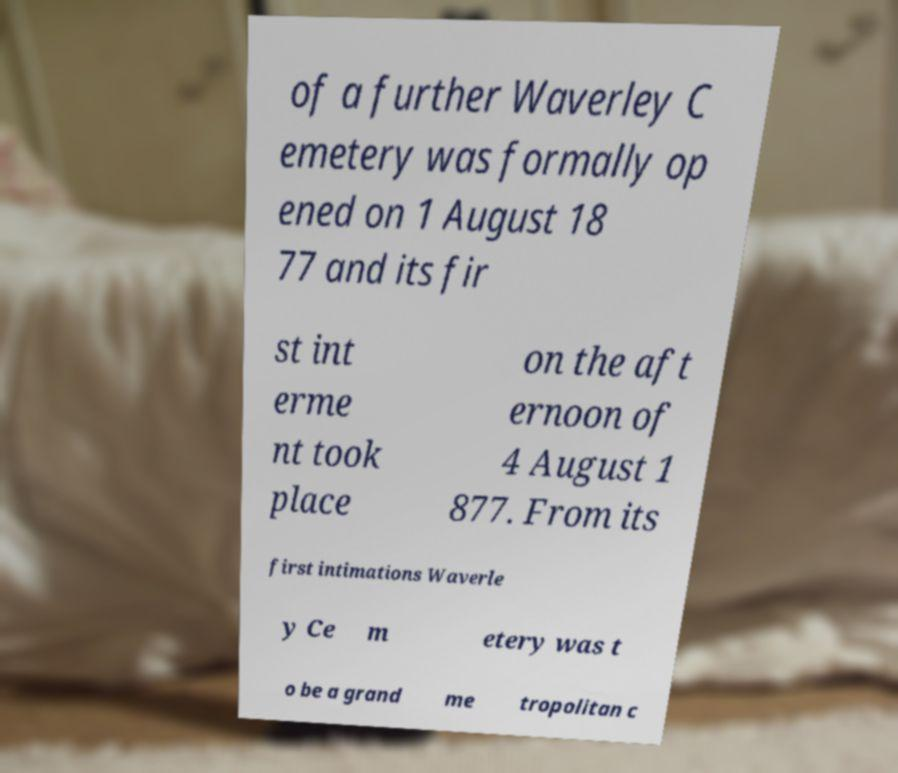Could you extract and type out the text from this image? of a further Waverley C emetery was formally op ened on 1 August 18 77 and its fir st int erme nt took place on the aft ernoon of 4 August 1 877. From its first intimations Waverle y Ce m etery was t o be a grand me tropolitan c 